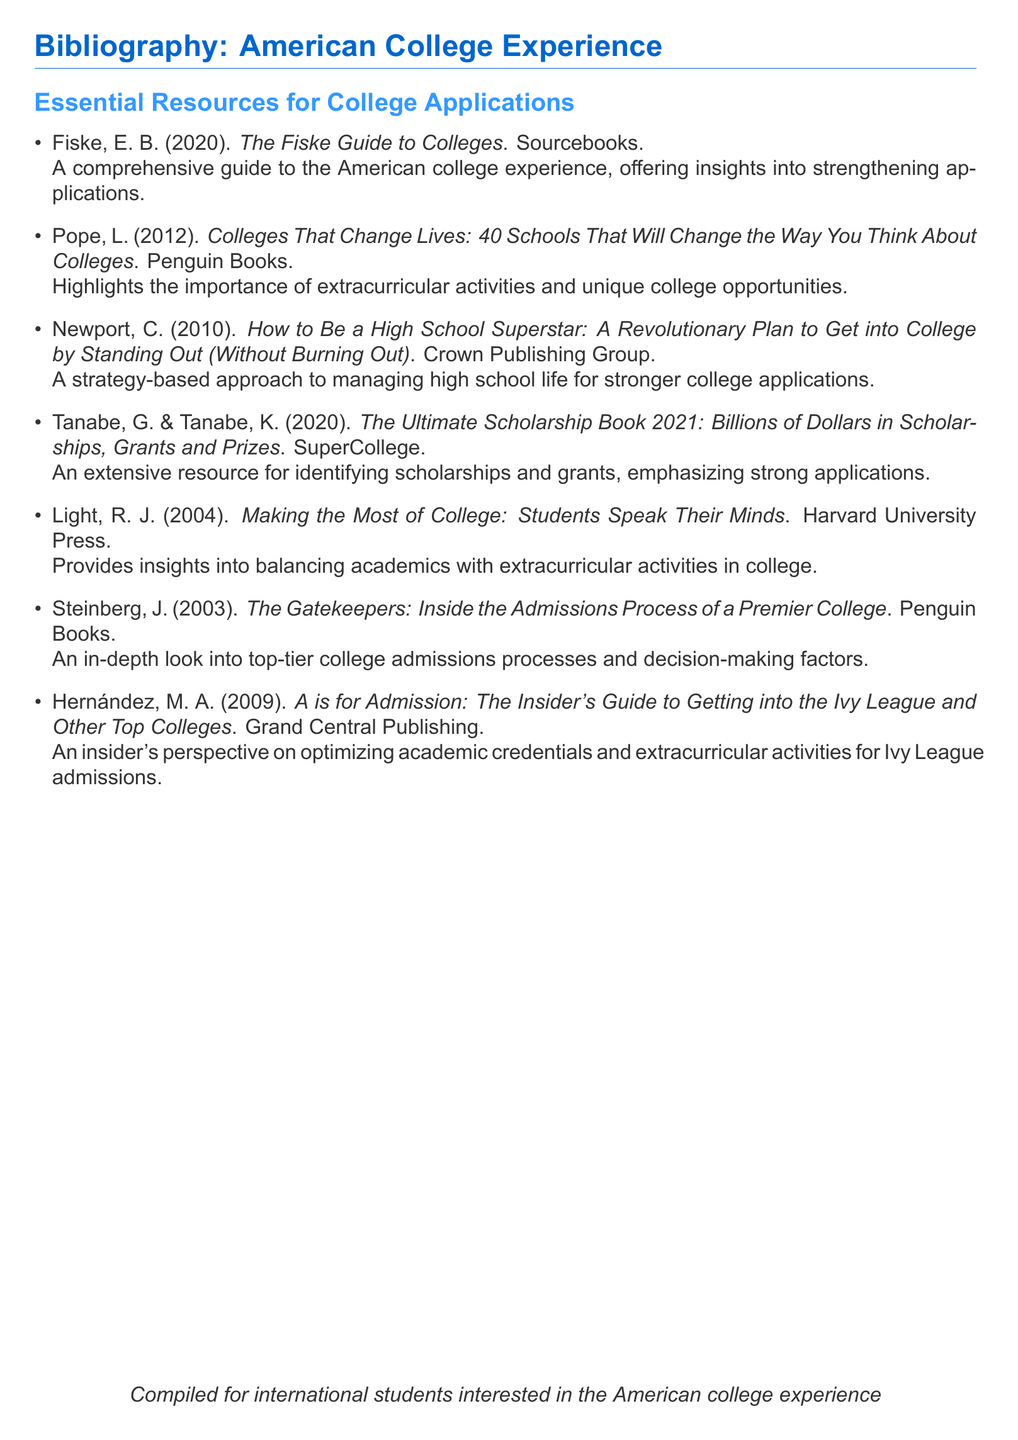What is the title of the first resource listed? The title of the first resource is the name of the book by Fiske listed in the document.
Answer: The Fiske Guide to Colleges Who authored the book "How to Be a High School Superstar"? This question asks for the author of a specific title mentioned in the bibliography.
Answer: Cal Newport In what year was "Colleges That Change Lives" published? This question seeks to find the publication year of a specific book listed in the document.
Answer: 2012 Which publishing company published "A is for Admission"? This question asks for the publisher of a particular book in the bibliography.
Answer: Grand Central Publishing How many schools are highlighted in "Colleges That Change Lives"? This question requires counting the number of schools mentioned in the title of the book by Pope.
Answer: 40 Which two authors wrote "The Ultimate Scholarship Book 2021"? This question requests the names of both authors of a specific resource from the document.
Answer: Tanabe, G. & Tanabe What is the main focus of "Making the Most of College"? This question looks for the general subject matter of the book mentioned in the bibliography.
Answer: Balancing academics with extracurricular activities What is the purpose of this bibliography? This question explores the intent or audience for the compiled resources in the document.
Answer: For international students interested in the American college experience 